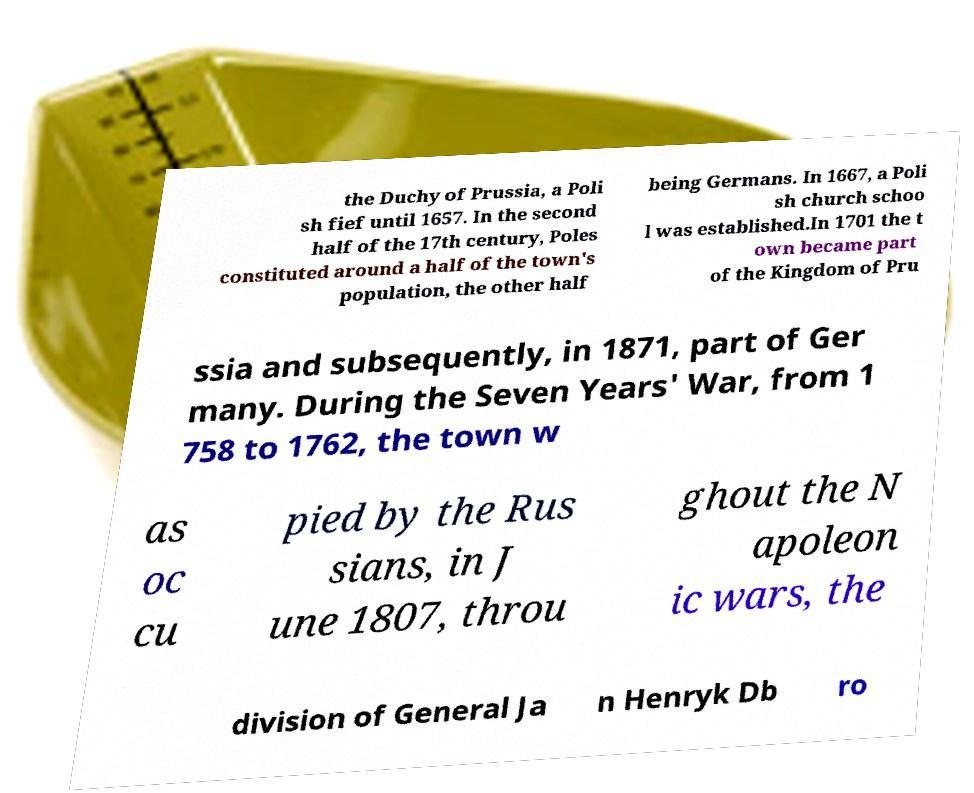Could you extract and type out the text from this image? the Duchy of Prussia, a Poli sh fief until 1657. In the second half of the 17th century, Poles constituted around a half of the town's population, the other half being Germans. In 1667, a Poli sh church schoo l was established.In 1701 the t own became part of the Kingdom of Pru ssia and subsequently, in 1871, part of Ger many. During the Seven Years' War, from 1 758 to 1762, the town w as oc cu pied by the Rus sians, in J une 1807, throu ghout the N apoleon ic wars, the division of General Ja n Henryk Db ro 